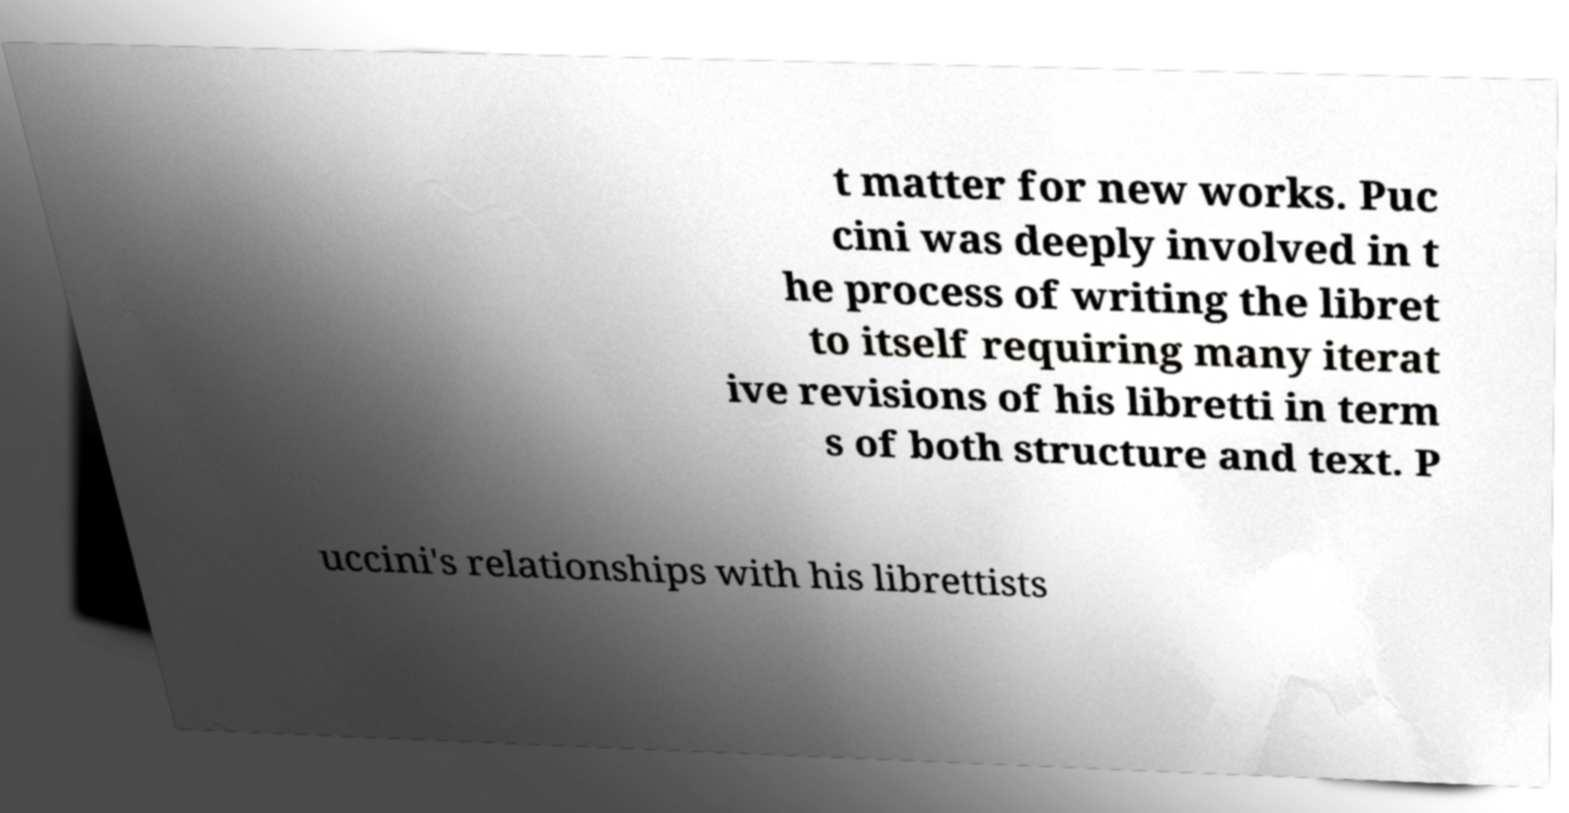Please read and relay the text visible in this image. What does it say? t matter for new works. Puc cini was deeply involved in t he process of writing the libret to itself requiring many iterat ive revisions of his libretti in term s of both structure and text. P uccini's relationships with his librettists 